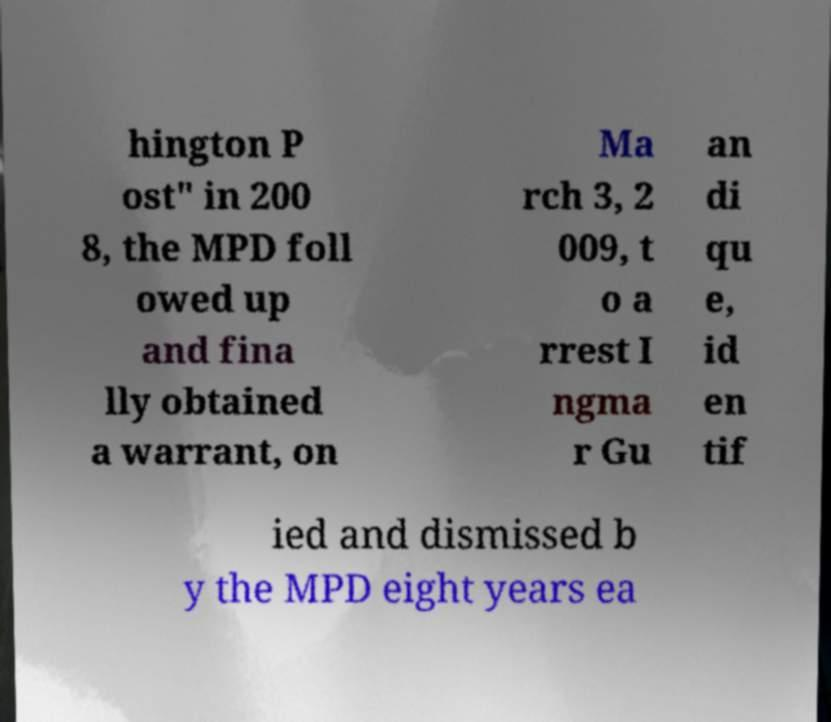Could you assist in decoding the text presented in this image and type it out clearly? hington P ost" in 200 8, the MPD foll owed up and fina lly obtained a warrant, on Ma rch 3, 2 009, t o a rrest I ngma r Gu an di qu e, id en tif ied and dismissed b y the MPD eight years ea 